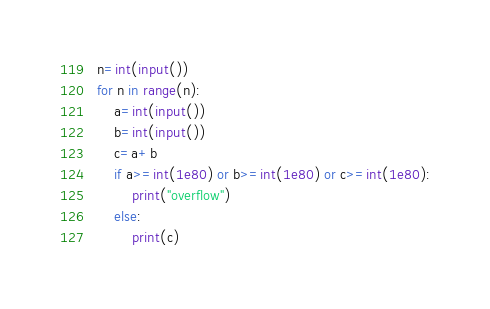Convert code to text. <code><loc_0><loc_0><loc_500><loc_500><_Python_>n=int(input())
for n in range(n):
	a=int(input())
	b=int(input())
	c=a+b
	if a>=int(1e80) or b>=int(1e80) or c>=int(1e80):
		print("overflow")
	else:
		print(c)</code> 